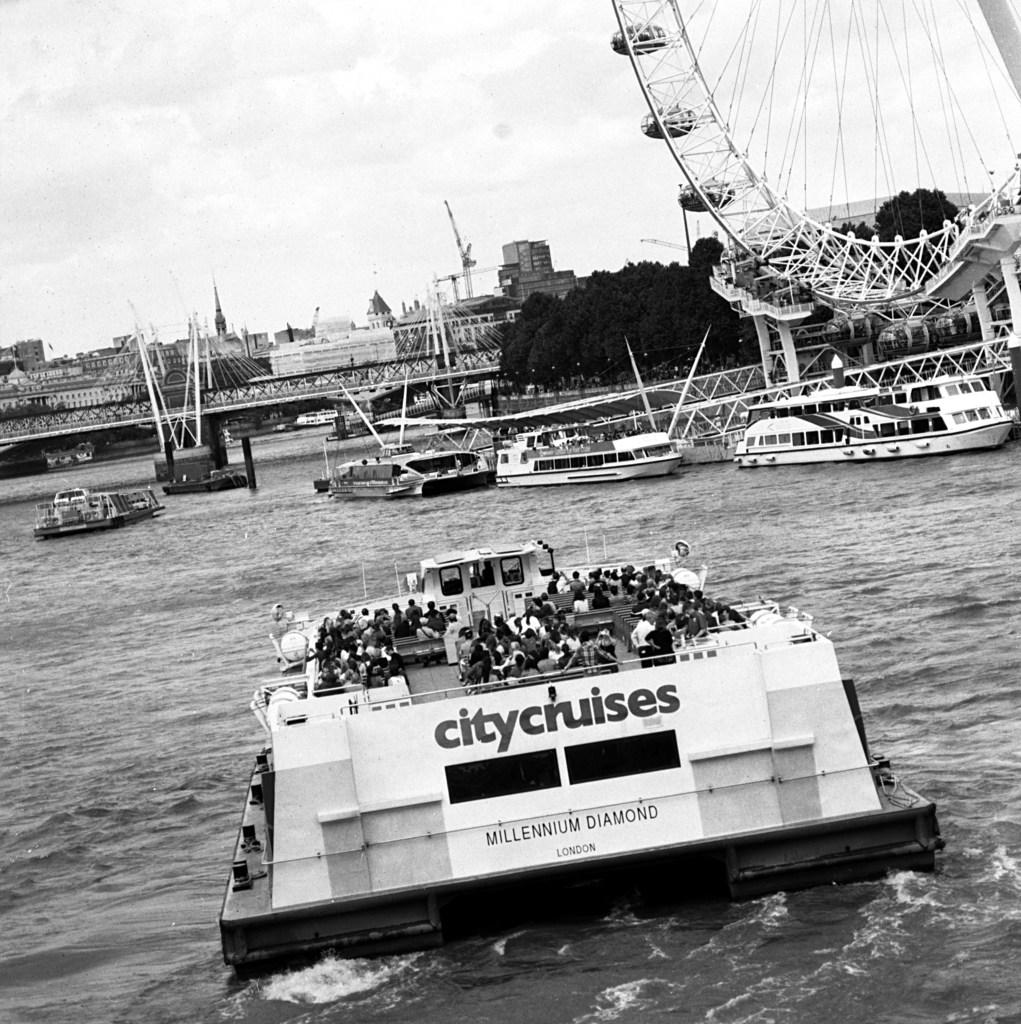What is the name of the boat?
Offer a very short reply. Millennium diamond. Where is this bridge?
Keep it short and to the point. Unanswerable. 